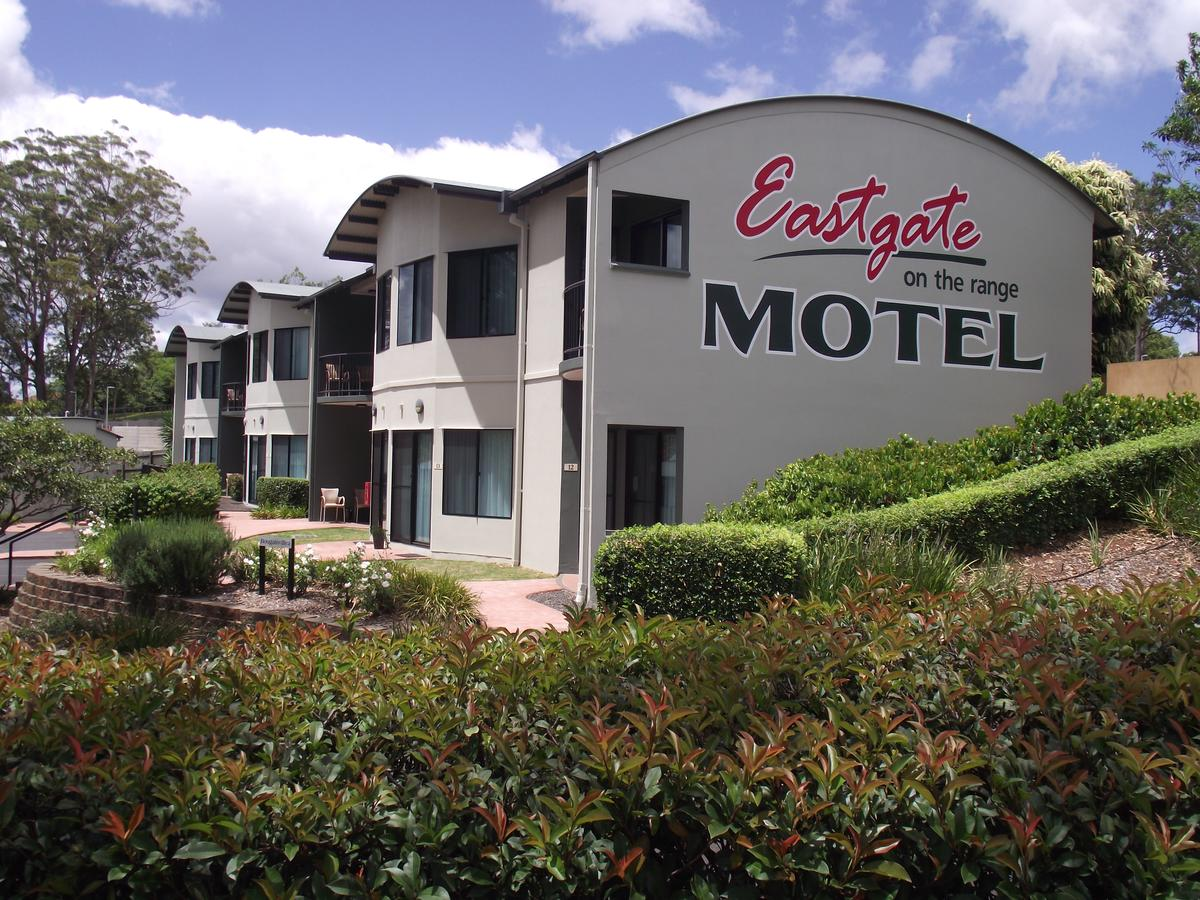Write a detailed description of this image, do not forget about the texts on it if they exist. Also, do not forget to mention the type / style of the image. The photograph captures a modern motel setting amidst lush greenery under a partly cloudy sky. The Eastgate on the range MOTEL, prominently displayed in large, stylized red and gray letters, adorns the building's curved facade. This two-story structure features a clean, gray exterior paired with dark roofing, contrasting nicely with the natural tones surrounding it. Multiple entryways and windows break the uniformity of the walls, with some upper-level rooms boasting small balconies framed by metal railings. Pathways of red brick weave through manicured shrubs and bushes, inviting visitors to explore the premises. The image is well-composed, offering viewers a clear glimpse into this serene motel environment in natural daylight. 